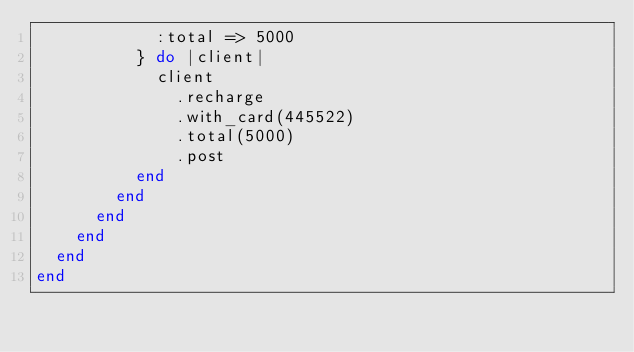<code> <loc_0><loc_0><loc_500><loc_500><_Ruby_>            :total => 5000
          } do |client|
            client
              .recharge
              .with_card(445522)
              .total(5000)
              .post
          end
        end
      end
    end
  end
end
</code> 